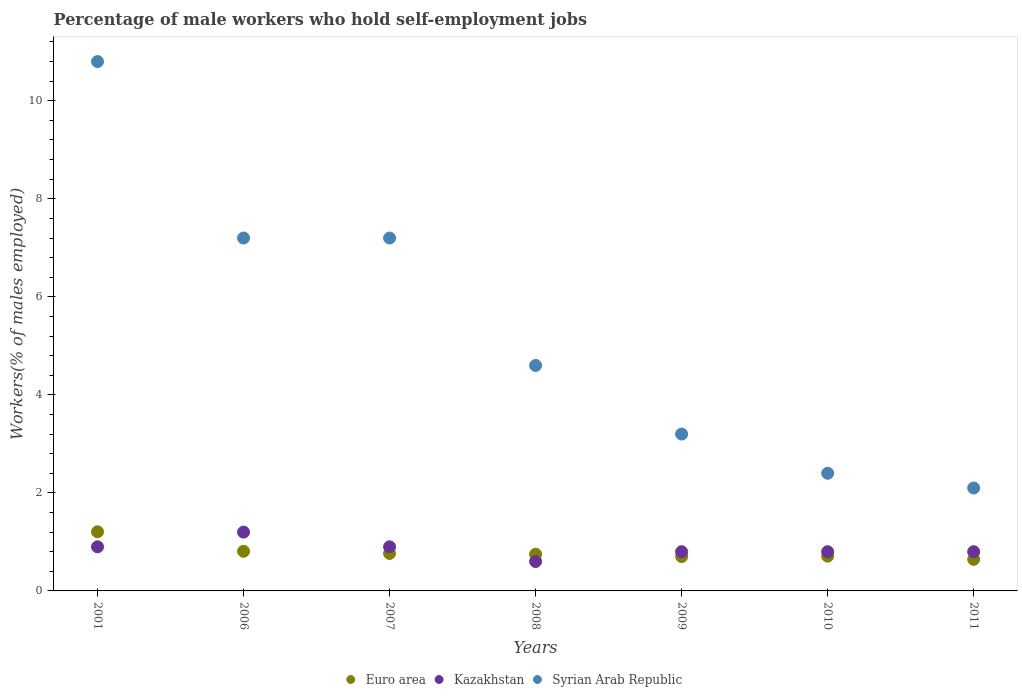What is the percentage of self-employed male workers in Kazakhstan in 2001?
Your response must be concise. 0.9. Across all years, what is the maximum percentage of self-employed male workers in Syrian Arab Republic?
Ensure brevity in your answer.  10.8. Across all years, what is the minimum percentage of self-employed male workers in Euro area?
Give a very brief answer. 0.64. What is the total percentage of self-employed male workers in Euro area in the graph?
Keep it short and to the point. 5.58. What is the difference between the percentage of self-employed male workers in Kazakhstan in 2006 and that in 2011?
Give a very brief answer. 0.4. What is the difference between the percentage of self-employed male workers in Syrian Arab Republic in 2011 and the percentage of self-employed male workers in Euro area in 2001?
Keep it short and to the point. 0.89. What is the average percentage of self-employed male workers in Syrian Arab Republic per year?
Offer a very short reply. 5.36. In the year 2009, what is the difference between the percentage of self-employed male workers in Kazakhstan and percentage of self-employed male workers in Euro area?
Provide a succinct answer. 0.1. What is the ratio of the percentage of self-employed male workers in Kazakhstan in 2001 to that in 2009?
Give a very brief answer. 1.12. Is the difference between the percentage of self-employed male workers in Kazakhstan in 2001 and 2011 greater than the difference between the percentage of self-employed male workers in Euro area in 2001 and 2011?
Your response must be concise. No. What is the difference between the highest and the second highest percentage of self-employed male workers in Kazakhstan?
Keep it short and to the point. 0.3. What is the difference between the highest and the lowest percentage of self-employed male workers in Syrian Arab Republic?
Offer a terse response. 8.7. In how many years, is the percentage of self-employed male workers in Syrian Arab Republic greater than the average percentage of self-employed male workers in Syrian Arab Republic taken over all years?
Make the answer very short. 3. Does the percentage of self-employed male workers in Kazakhstan monotonically increase over the years?
Provide a short and direct response. No. How many dotlines are there?
Offer a terse response. 3. Does the graph contain grids?
Make the answer very short. No. How many legend labels are there?
Provide a succinct answer. 3. How are the legend labels stacked?
Make the answer very short. Horizontal. What is the title of the graph?
Keep it short and to the point. Percentage of male workers who hold self-employment jobs. Does "Sint Maarten (Dutch part)" appear as one of the legend labels in the graph?
Make the answer very short. No. What is the label or title of the X-axis?
Provide a short and direct response. Years. What is the label or title of the Y-axis?
Make the answer very short. Workers(% of males employed). What is the Workers(% of males employed) of Euro area in 2001?
Your answer should be very brief. 1.21. What is the Workers(% of males employed) of Kazakhstan in 2001?
Provide a short and direct response. 0.9. What is the Workers(% of males employed) in Syrian Arab Republic in 2001?
Offer a terse response. 10.8. What is the Workers(% of males employed) of Euro area in 2006?
Offer a very short reply. 0.81. What is the Workers(% of males employed) in Kazakhstan in 2006?
Offer a terse response. 1.2. What is the Workers(% of males employed) in Syrian Arab Republic in 2006?
Provide a succinct answer. 7.2. What is the Workers(% of males employed) in Euro area in 2007?
Your answer should be compact. 0.76. What is the Workers(% of males employed) of Kazakhstan in 2007?
Your answer should be compact. 0.9. What is the Workers(% of males employed) of Syrian Arab Republic in 2007?
Give a very brief answer. 7.2. What is the Workers(% of males employed) in Euro area in 2008?
Ensure brevity in your answer.  0.75. What is the Workers(% of males employed) in Kazakhstan in 2008?
Offer a very short reply. 0.6. What is the Workers(% of males employed) of Syrian Arab Republic in 2008?
Provide a short and direct response. 4.6. What is the Workers(% of males employed) in Euro area in 2009?
Offer a terse response. 0.7. What is the Workers(% of males employed) of Kazakhstan in 2009?
Your answer should be compact. 0.8. What is the Workers(% of males employed) of Syrian Arab Republic in 2009?
Your answer should be very brief. 3.2. What is the Workers(% of males employed) in Euro area in 2010?
Offer a terse response. 0.71. What is the Workers(% of males employed) in Kazakhstan in 2010?
Offer a terse response. 0.8. What is the Workers(% of males employed) in Syrian Arab Republic in 2010?
Keep it short and to the point. 2.4. What is the Workers(% of males employed) in Euro area in 2011?
Make the answer very short. 0.64. What is the Workers(% of males employed) in Kazakhstan in 2011?
Keep it short and to the point. 0.8. What is the Workers(% of males employed) of Syrian Arab Republic in 2011?
Ensure brevity in your answer.  2.1. Across all years, what is the maximum Workers(% of males employed) in Euro area?
Offer a very short reply. 1.21. Across all years, what is the maximum Workers(% of males employed) of Kazakhstan?
Ensure brevity in your answer.  1.2. Across all years, what is the maximum Workers(% of males employed) of Syrian Arab Republic?
Provide a succinct answer. 10.8. Across all years, what is the minimum Workers(% of males employed) of Euro area?
Keep it short and to the point. 0.64. Across all years, what is the minimum Workers(% of males employed) in Kazakhstan?
Provide a succinct answer. 0.6. Across all years, what is the minimum Workers(% of males employed) of Syrian Arab Republic?
Keep it short and to the point. 2.1. What is the total Workers(% of males employed) in Euro area in the graph?
Ensure brevity in your answer.  5.58. What is the total Workers(% of males employed) in Syrian Arab Republic in the graph?
Make the answer very short. 37.5. What is the difference between the Workers(% of males employed) of Euro area in 2001 and that in 2006?
Offer a very short reply. 0.4. What is the difference between the Workers(% of males employed) in Kazakhstan in 2001 and that in 2006?
Give a very brief answer. -0.3. What is the difference between the Workers(% of males employed) in Syrian Arab Republic in 2001 and that in 2006?
Make the answer very short. 3.6. What is the difference between the Workers(% of males employed) in Euro area in 2001 and that in 2007?
Make the answer very short. 0.44. What is the difference between the Workers(% of males employed) of Syrian Arab Republic in 2001 and that in 2007?
Your answer should be compact. 3.6. What is the difference between the Workers(% of males employed) of Euro area in 2001 and that in 2008?
Ensure brevity in your answer.  0.46. What is the difference between the Workers(% of males employed) in Syrian Arab Republic in 2001 and that in 2008?
Provide a succinct answer. 6.2. What is the difference between the Workers(% of males employed) of Euro area in 2001 and that in 2009?
Your response must be concise. 0.51. What is the difference between the Workers(% of males employed) in Kazakhstan in 2001 and that in 2009?
Offer a very short reply. 0.1. What is the difference between the Workers(% of males employed) of Euro area in 2001 and that in 2010?
Give a very brief answer. 0.5. What is the difference between the Workers(% of males employed) of Kazakhstan in 2001 and that in 2010?
Your answer should be compact. 0.1. What is the difference between the Workers(% of males employed) of Syrian Arab Republic in 2001 and that in 2010?
Ensure brevity in your answer.  8.4. What is the difference between the Workers(% of males employed) of Euro area in 2001 and that in 2011?
Your answer should be very brief. 0.56. What is the difference between the Workers(% of males employed) of Kazakhstan in 2001 and that in 2011?
Offer a terse response. 0.1. What is the difference between the Workers(% of males employed) in Syrian Arab Republic in 2001 and that in 2011?
Provide a short and direct response. 8.7. What is the difference between the Workers(% of males employed) in Euro area in 2006 and that in 2007?
Make the answer very short. 0.04. What is the difference between the Workers(% of males employed) in Kazakhstan in 2006 and that in 2007?
Your response must be concise. 0.3. What is the difference between the Workers(% of males employed) of Syrian Arab Republic in 2006 and that in 2007?
Offer a terse response. 0. What is the difference between the Workers(% of males employed) in Euro area in 2006 and that in 2008?
Your answer should be very brief. 0.06. What is the difference between the Workers(% of males employed) of Kazakhstan in 2006 and that in 2008?
Keep it short and to the point. 0.6. What is the difference between the Workers(% of males employed) of Euro area in 2006 and that in 2009?
Keep it short and to the point. 0.11. What is the difference between the Workers(% of males employed) in Kazakhstan in 2006 and that in 2009?
Provide a succinct answer. 0.4. What is the difference between the Workers(% of males employed) of Syrian Arab Republic in 2006 and that in 2009?
Offer a very short reply. 4. What is the difference between the Workers(% of males employed) in Euro area in 2006 and that in 2010?
Offer a very short reply. 0.1. What is the difference between the Workers(% of males employed) of Euro area in 2006 and that in 2011?
Your answer should be very brief. 0.16. What is the difference between the Workers(% of males employed) of Syrian Arab Republic in 2006 and that in 2011?
Keep it short and to the point. 5.1. What is the difference between the Workers(% of males employed) in Euro area in 2007 and that in 2008?
Provide a succinct answer. 0.01. What is the difference between the Workers(% of males employed) of Kazakhstan in 2007 and that in 2008?
Ensure brevity in your answer.  0.3. What is the difference between the Workers(% of males employed) of Euro area in 2007 and that in 2009?
Your response must be concise. 0.06. What is the difference between the Workers(% of males employed) in Syrian Arab Republic in 2007 and that in 2009?
Ensure brevity in your answer.  4. What is the difference between the Workers(% of males employed) in Euro area in 2007 and that in 2010?
Your response must be concise. 0.06. What is the difference between the Workers(% of males employed) of Kazakhstan in 2007 and that in 2010?
Your answer should be very brief. 0.1. What is the difference between the Workers(% of males employed) in Euro area in 2007 and that in 2011?
Your response must be concise. 0.12. What is the difference between the Workers(% of males employed) of Kazakhstan in 2007 and that in 2011?
Your response must be concise. 0.1. What is the difference between the Workers(% of males employed) of Euro area in 2008 and that in 2009?
Keep it short and to the point. 0.05. What is the difference between the Workers(% of males employed) of Euro area in 2008 and that in 2011?
Keep it short and to the point. 0.1. What is the difference between the Workers(% of males employed) in Kazakhstan in 2008 and that in 2011?
Offer a very short reply. -0.2. What is the difference between the Workers(% of males employed) in Syrian Arab Republic in 2008 and that in 2011?
Your answer should be compact. 2.5. What is the difference between the Workers(% of males employed) in Euro area in 2009 and that in 2010?
Your response must be concise. -0.01. What is the difference between the Workers(% of males employed) of Kazakhstan in 2009 and that in 2010?
Ensure brevity in your answer.  0. What is the difference between the Workers(% of males employed) in Euro area in 2009 and that in 2011?
Your answer should be very brief. 0.06. What is the difference between the Workers(% of males employed) of Kazakhstan in 2009 and that in 2011?
Give a very brief answer. 0. What is the difference between the Workers(% of males employed) in Euro area in 2010 and that in 2011?
Offer a very short reply. 0.06. What is the difference between the Workers(% of males employed) in Kazakhstan in 2010 and that in 2011?
Keep it short and to the point. 0. What is the difference between the Workers(% of males employed) in Euro area in 2001 and the Workers(% of males employed) in Kazakhstan in 2006?
Offer a terse response. 0.01. What is the difference between the Workers(% of males employed) of Euro area in 2001 and the Workers(% of males employed) of Syrian Arab Republic in 2006?
Give a very brief answer. -5.99. What is the difference between the Workers(% of males employed) of Kazakhstan in 2001 and the Workers(% of males employed) of Syrian Arab Republic in 2006?
Make the answer very short. -6.3. What is the difference between the Workers(% of males employed) in Euro area in 2001 and the Workers(% of males employed) in Kazakhstan in 2007?
Give a very brief answer. 0.31. What is the difference between the Workers(% of males employed) in Euro area in 2001 and the Workers(% of males employed) in Syrian Arab Republic in 2007?
Your answer should be very brief. -5.99. What is the difference between the Workers(% of males employed) in Kazakhstan in 2001 and the Workers(% of males employed) in Syrian Arab Republic in 2007?
Your answer should be compact. -6.3. What is the difference between the Workers(% of males employed) of Euro area in 2001 and the Workers(% of males employed) of Kazakhstan in 2008?
Make the answer very short. 0.61. What is the difference between the Workers(% of males employed) of Euro area in 2001 and the Workers(% of males employed) of Syrian Arab Republic in 2008?
Your answer should be very brief. -3.39. What is the difference between the Workers(% of males employed) of Kazakhstan in 2001 and the Workers(% of males employed) of Syrian Arab Republic in 2008?
Ensure brevity in your answer.  -3.7. What is the difference between the Workers(% of males employed) in Euro area in 2001 and the Workers(% of males employed) in Kazakhstan in 2009?
Ensure brevity in your answer.  0.41. What is the difference between the Workers(% of males employed) of Euro area in 2001 and the Workers(% of males employed) of Syrian Arab Republic in 2009?
Make the answer very short. -1.99. What is the difference between the Workers(% of males employed) of Euro area in 2001 and the Workers(% of males employed) of Kazakhstan in 2010?
Offer a very short reply. 0.41. What is the difference between the Workers(% of males employed) in Euro area in 2001 and the Workers(% of males employed) in Syrian Arab Republic in 2010?
Your answer should be compact. -1.19. What is the difference between the Workers(% of males employed) of Euro area in 2001 and the Workers(% of males employed) of Kazakhstan in 2011?
Make the answer very short. 0.41. What is the difference between the Workers(% of males employed) in Euro area in 2001 and the Workers(% of males employed) in Syrian Arab Republic in 2011?
Give a very brief answer. -0.89. What is the difference between the Workers(% of males employed) of Euro area in 2006 and the Workers(% of males employed) of Kazakhstan in 2007?
Offer a very short reply. -0.09. What is the difference between the Workers(% of males employed) in Euro area in 2006 and the Workers(% of males employed) in Syrian Arab Republic in 2007?
Make the answer very short. -6.39. What is the difference between the Workers(% of males employed) in Kazakhstan in 2006 and the Workers(% of males employed) in Syrian Arab Republic in 2007?
Offer a terse response. -6. What is the difference between the Workers(% of males employed) in Euro area in 2006 and the Workers(% of males employed) in Kazakhstan in 2008?
Make the answer very short. 0.21. What is the difference between the Workers(% of males employed) of Euro area in 2006 and the Workers(% of males employed) of Syrian Arab Republic in 2008?
Give a very brief answer. -3.79. What is the difference between the Workers(% of males employed) of Kazakhstan in 2006 and the Workers(% of males employed) of Syrian Arab Republic in 2008?
Your answer should be very brief. -3.4. What is the difference between the Workers(% of males employed) of Euro area in 2006 and the Workers(% of males employed) of Kazakhstan in 2009?
Ensure brevity in your answer.  0.01. What is the difference between the Workers(% of males employed) of Euro area in 2006 and the Workers(% of males employed) of Syrian Arab Republic in 2009?
Keep it short and to the point. -2.39. What is the difference between the Workers(% of males employed) in Kazakhstan in 2006 and the Workers(% of males employed) in Syrian Arab Republic in 2009?
Offer a terse response. -2. What is the difference between the Workers(% of males employed) in Euro area in 2006 and the Workers(% of males employed) in Kazakhstan in 2010?
Your answer should be compact. 0.01. What is the difference between the Workers(% of males employed) of Euro area in 2006 and the Workers(% of males employed) of Syrian Arab Republic in 2010?
Give a very brief answer. -1.59. What is the difference between the Workers(% of males employed) of Euro area in 2006 and the Workers(% of males employed) of Kazakhstan in 2011?
Ensure brevity in your answer.  0.01. What is the difference between the Workers(% of males employed) of Euro area in 2006 and the Workers(% of males employed) of Syrian Arab Republic in 2011?
Make the answer very short. -1.29. What is the difference between the Workers(% of males employed) of Kazakhstan in 2006 and the Workers(% of males employed) of Syrian Arab Republic in 2011?
Your answer should be very brief. -0.9. What is the difference between the Workers(% of males employed) of Euro area in 2007 and the Workers(% of males employed) of Kazakhstan in 2008?
Your answer should be very brief. 0.16. What is the difference between the Workers(% of males employed) in Euro area in 2007 and the Workers(% of males employed) in Syrian Arab Republic in 2008?
Provide a succinct answer. -3.84. What is the difference between the Workers(% of males employed) in Kazakhstan in 2007 and the Workers(% of males employed) in Syrian Arab Republic in 2008?
Ensure brevity in your answer.  -3.7. What is the difference between the Workers(% of males employed) in Euro area in 2007 and the Workers(% of males employed) in Kazakhstan in 2009?
Provide a succinct answer. -0.04. What is the difference between the Workers(% of males employed) in Euro area in 2007 and the Workers(% of males employed) in Syrian Arab Republic in 2009?
Your response must be concise. -2.44. What is the difference between the Workers(% of males employed) of Kazakhstan in 2007 and the Workers(% of males employed) of Syrian Arab Republic in 2009?
Your answer should be compact. -2.3. What is the difference between the Workers(% of males employed) in Euro area in 2007 and the Workers(% of males employed) in Kazakhstan in 2010?
Your response must be concise. -0.04. What is the difference between the Workers(% of males employed) in Euro area in 2007 and the Workers(% of males employed) in Syrian Arab Republic in 2010?
Provide a succinct answer. -1.64. What is the difference between the Workers(% of males employed) in Kazakhstan in 2007 and the Workers(% of males employed) in Syrian Arab Republic in 2010?
Give a very brief answer. -1.5. What is the difference between the Workers(% of males employed) of Euro area in 2007 and the Workers(% of males employed) of Kazakhstan in 2011?
Give a very brief answer. -0.04. What is the difference between the Workers(% of males employed) of Euro area in 2007 and the Workers(% of males employed) of Syrian Arab Republic in 2011?
Keep it short and to the point. -1.34. What is the difference between the Workers(% of males employed) in Euro area in 2008 and the Workers(% of males employed) in Kazakhstan in 2009?
Provide a short and direct response. -0.05. What is the difference between the Workers(% of males employed) of Euro area in 2008 and the Workers(% of males employed) of Syrian Arab Republic in 2009?
Provide a succinct answer. -2.45. What is the difference between the Workers(% of males employed) of Kazakhstan in 2008 and the Workers(% of males employed) of Syrian Arab Republic in 2009?
Your answer should be compact. -2.6. What is the difference between the Workers(% of males employed) in Euro area in 2008 and the Workers(% of males employed) in Kazakhstan in 2010?
Your answer should be very brief. -0.05. What is the difference between the Workers(% of males employed) of Euro area in 2008 and the Workers(% of males employed) of Syrian Arab Republic in 2010?
Give a very brief answer. -1.65. What is the difference between the Workers(% of males employed) in Euro area in 2008 and the Workers(% of males employed) in Kazakhstan in 2011?
Offer a terse response. -0.05. What is the difference between the Workers(% of males employed) in Euro area in 2008 and the Workers(% of males employed) in Syrian Arab Republic in 2011?
Provide a succinct answer. -1.35. What is the difference between the Workers(% of males employed) of Kazakhstan in 2008 and the Workers(% of males employed) of Syrian Arab Republic in 2011?
Provide a succinct answer. -1.5. What is the difference between the Workers(% of males employed) of Euro area in 2009 and the Workers(% of males employed) of Kazakhstan in 2010?
Make the answer very short. -0.1. What is the difference between the Workers(% of males employed) in Euro area in 2009 and the Workers(% of males employed) in Syrian Arab Republic in 2010?
Your answer should be very brief. -1.7. What is the difference between the Workers(% of males employed) in Kazakhstan in 2009 and the Workers(% of males employed) in Syrian Arab Republic in 2010?
Keep it short and to the point. -1.6. What is the difference between the Workers(% of males employed) of Euro area in 2009 and the Workers(% of males employed) of Kazakhstan in 2011?
Give a very brief answer. -0.1. What is the difference between the Workers(% of males employed) in Euro area in 2009 and the Workers(% of males employed) in Syrian Arab Republic in 2011?
Ensure brevity in your answer.  -1.4. What is the difference between the Workers(% of males employed) in Euro area in 2010 and the Workers(% of males employed) in Kazakhstan in 2011?
Provide a succinct answer. -0.09. What is the difference between the Workers(% of males employed) in Euro area in 2010 and the Workers(% of males employed) in Syrian Arab Republic in 2011?
Your answer should be compact. -1.39. What is the difference between the Workers(% of males employed) of Kazakhstan in 2010 and the Workers(% of males employed) of Syrian Arab Republic in 2011?
Your answer should be compact. -1.3. What is the average Workers(% of males employed) in Euro area per year?
Make the answer very short. 0.8. What is the average Workers(% of males employed) of Syrian Arab Republic per year?
Make the answer very short. 5.36. In the year 2001, what is the difference between the Workers(% of males employed) in Euro area and Workers(% of males employed) in Kazakhstan?
Your answer should be very brief. 0.31. In the year 2001, what is the difference between the Workers(% of males employed) of Euro area and Workers(% of males employed) of Syrian Arab Republic?
Offer a very short reply. -9.59. In the year 2001, what is the difference between the Workers(% of males employed) in Kazakhstan and Workers(% of males employed) in Syrian Arab Republic?
Give a very brief answer. -9.9. In the year 2006, what is the difference between the Workers(% of males employed) in Euro area and Workers(% of males employed) in Kazakhstan?
Your answer should be compact. -0.39. In the year 2006, what is the difference between the Workers(% of males employed) of Euro area and Workers(% of males employed) of Syrian Arab Republic?
Ensure brevity in your answer.  -6.39. In the year 2006, what is the difference between the Workers(% of males employed) in Kazakhstan and Workers(% of males employed) in Syrian Arab Republic?
Offer a terse response. -6. In the year 2007, what is the difference between the Workers(% of males employed) in Euro area and Workers(% of males employed) in Kazakhstan?
Ensure brevity in your answer.  -0.14. In the year 2007, what is the difference between the Workers(% of males employed) of Euro area and Workers(% of males employed) of Syrian Arab Republic?
Provide a succinct answer. -6.44. In the year 2008, what is the difference between the Workers(% of males employed) in Euro area and Workers(% of males employed) in Kazakhstan?
Keep it short and to the point. 0.15. In the year 2008, what is the difference between the Workers(% of males employed) in Euro area and Workers(% of males employed) in Syrian Arab Republic?
Provide a short and direct response. -3.85. In the year 2009, what is the difference between the Workers(% of males employed) of Euro area and Workers(% of males employed) of Kazakhstan?
Keep it short and to the point. -0.1. In the year 2009, what is the difference between the Workers(% of males employed) in Euro area and Workers(% of males employed) in Syrian Arab Republic?
Your response must be concise. -2.5. In the year 2009, what is the difference between the Workers(% of males employed) of Kazakhstan and Workers(% of males employed) of Syrian Arab Republic?
Provide a short and direct response. -2.4. In the year 2010, what is the difference between the Workers(% of males employed) in Euro area and Workers(% of males employed) in Kazakhstan?
Provide a succinct answer. -0.09. In the year 2010, what is the difference between the Workers(% of males employed) of Euro area and Workers(% of males employed) of Syrian Arab Republic?
Provide a succinct answer. -1.69. In the year 2011, what is the difference between the Workers(% of males employed) in Euro area and Workers(% of males employed) in Kazakhstan?
Your response must be concise. -0.16. In the year 2011, what is the difference between the Workers(% of males employed) of Euro area and Workers(% of males employed) of Syrian Arab Republic?
Ensure brevity in your answer.  -1.46. In the year 2011, what is the difference between the Workers(% of males employed) of Kazakhstan and Workers(% of males employed) of Syrian Arab Republic?
Offer a terse response. -1.3. What is the ratio of the Workers(% of males employed) in Euro area in 2001 to that in 2006?
Keep it short and to the point. 1.49. What is the ratio of the Workers(% of males employed) of Kazakhstan in 2001 to that in 2006?
Your answer should be very brief. 0.75. What is the ratio of the Workers(% of males employed) in Syrian Arab Republic in 2001 to that in 2006?
Offer a very short reply. 1.5. What is the ratio of the Workers(% of males employed) of Euro area in 2001 to that in 2007?
Offer a very short reply. 1.58. What is the ratio of the Workers(% of males employed) of Syrian Arab Republic in 2001 to that in 2007?
Provide a succinct answer. 1.5. What is the ratio of the Workers(% of males employed) of Euro area in 2001 to that in 2008?
Offer a terse response. 1.61. What is the ratio of the Workers(% of males employed) of Syrian Arab Republic in 2001 to that in 2008?
Ensure brevity in your answer.  2.35. What is the ratio of the Workers(% of males employed) in Euro area in 2001 to that in 2009?
Offer a terse response. 1.72. What is the ratio of the Workers(% of males employed) in Syrian Arab Republic in 2001 to that in 2009?
Your answer should be very brief. 3.38. What is the ratio of the Workers(% of males employed) in Euro area in 2001 to that in 2010?
Offer a very short reply. 1.7. What is the ratio of the Workers(% of males employed) in Euro area in 2001 to that in 2011?
Keep it short and to the point. 1.87. What is the ratio of the Workers(% of males employed) in Syrian Arab Republic in 2001 to that in 2011?
Offer a very short reply. 5.14. What is the ratio of the Workers(% of males employed) of Euro area in 2006 to that in 2007?
Keep it short and to the point. 1.06. What is the ratio of the Workers(% of males employed) in Kazakhstan in 2006 to that in 2007?
Your answer should be compact. 1.33. What is the ratio of the Workers(% of males employed) in Euro area in 2006 to that in 2008?
Provide a succinct answer. 1.08. What is the ratio of the Workers(% of males employed) of Kazakhstan in 2006 to that in 2008?
Offer a very short reply. 2. What is the ratio of the Workers(% of males employed) in Syrian Arab Republic in 2006 to that in 2008?
Your response must be concise. 1.57. What is the ratio of the Workers(% of males employed) in Euro area in 2006 to that in 2009?
Offer a very short reply. 1.16. What is the ratio of the Workers(% of males employed) in Syrian Arab Republic in 2006 to that in 2009?
Make the answer very short. 2.25. What is the ratio of the Workers(% of males employed) in Euro area in 2006 to that in 2010?
Give a very brief answer. 1.14. What is the ratio of the Workers(% of males employed) of Syrian Arab Republic in 2006 to that in 2010?
Offer a terse response. 3. What is the ratio of the Workers(% of males employed) in Euro area in 2006 to that in 2011?
Ensure brevity in your answer.  1.25. What is the ratio of the Workers(% of males employed) in Kazakhstan in 2006 to that in 2011?
Offer a very short reply. 1.5. What is the ratio of the Workers(% of males employed) in Syrian Arab Republic in 2006 to that in 2011?
Keep it short and to the point. 3.43. What is the ratio of the Workers(% of males employed) in Euro area in 2007 to that in 2008?
Provide a succinct answer. 1.02. What is the ratio of the Workers(% of males employed) of Kazakhstan in 2007 to that in 2008?
Your answer should be very brief. 1.5. What is the ratio of the Workers(% of males employed) in Syrian Arab Republic in 2007 to that in 2008?
Provide a short and direct response. 1.57. What is the ratio of the Workers(% of males employed) in Euro area in 2007 to that in 2009?
Offer a very short reply. 1.09. What is the ratio of the Workers(% of males employed) in Kazakhstan in 2007 to that in 2009?
Offer a very short reply. 1.12. What is the ratio of the Workers(% of males employed) of Syrian Arab Republic in 2007 to that in 2009?
Your answer should be very brief. 2.25. What is the ratio of the Workers(% of males employed) in Euro area in 2007 to that in 2010?
Your answer should be very brief. 1.08. What is the ratio of the Workers(% of males employed) of Kazakhstan in 2007 to that in 2010?
Make the answer very short. 1.12. What is the ratio of the Workers(% of males employed) in Euro area in 2007 to that in 2011?
Your answer should be very brief. 1.19. What is the ratio of the Workers(% of males employed) in Syrian Arab Republic in 2007 to that in 2011?
Make the answer very short. 3.43. What is the ratio of the Workers(% of males employed) in Euro area in 2008 to that in 2009?
Offer a very short reply. 1.07. What is the ratio of the Workers(% of males employed) of Syrian Arab Republic in 2008 to that in 2009?
Offer a terse response. 1.44. What is the ratio of the Workers(% of males employed) of Euro area in 2008 to that in 2010?
Ensure brevity in your answer.  1.06. What is the ratio of the Workers(% of males employed) in Syrian Arab Republic in 2008 to that in 2010?
Your response must be concise. 1.92. What is the ratio of the Workers(% of males employed) of Euro area in 2008 to that in 2011?
Offer a terse response. 1.16. What is the ratio of the Workers(% of males employed) of Syrian Arab Republic in 2008 to that in 2011?
Keep it short and to the point. 2.19. What is the ratio of the Workers(% of males employed) of Euro area in 2009 to that in 2010?
Provide a succinct answer. 0.99. What is the ratio of the Workers(% of males employed) of Kazakhstan in 2009 to that in 2010?
Provide a short and direct response. 1. What is the ratio of the Workers(% of males employed) in Euro area in 2009 to that in 2011?
Provide a short and direct response. 1.09. What is the ratio of the Workers(% of males employed) in Syrian Arab Republic in 2009 to that in 2011?
Your response must be concise. 1.52. What is the ratio of the Workers(% of males employed) in Euro area in 2010 to that in 2011?
Your response must be concise. 1.1. What is the ratio of the Workers(% of males employed) in Kazakhstan in 2010 to that in 2011?
Keep it short and to the point. 1. What is the difference between the highest and the second highest Workers(% of males employed) of Euro area?
Provide a short and direct response. 0.4. What is the difference between the highest and the second highest Workers(% of males employed) of Syrian Arab Republic?
Your answer should be compact. 3.6. What is the difference between the highest and the lowest Workers(% of males employed) of Euro area?
Provide a succinct answer. 0.56. What is the difference between the highest and the lowest Workers(% of males employed) in Syrian Arab Republic?
Ensure brevity in your answer.  8.7. 